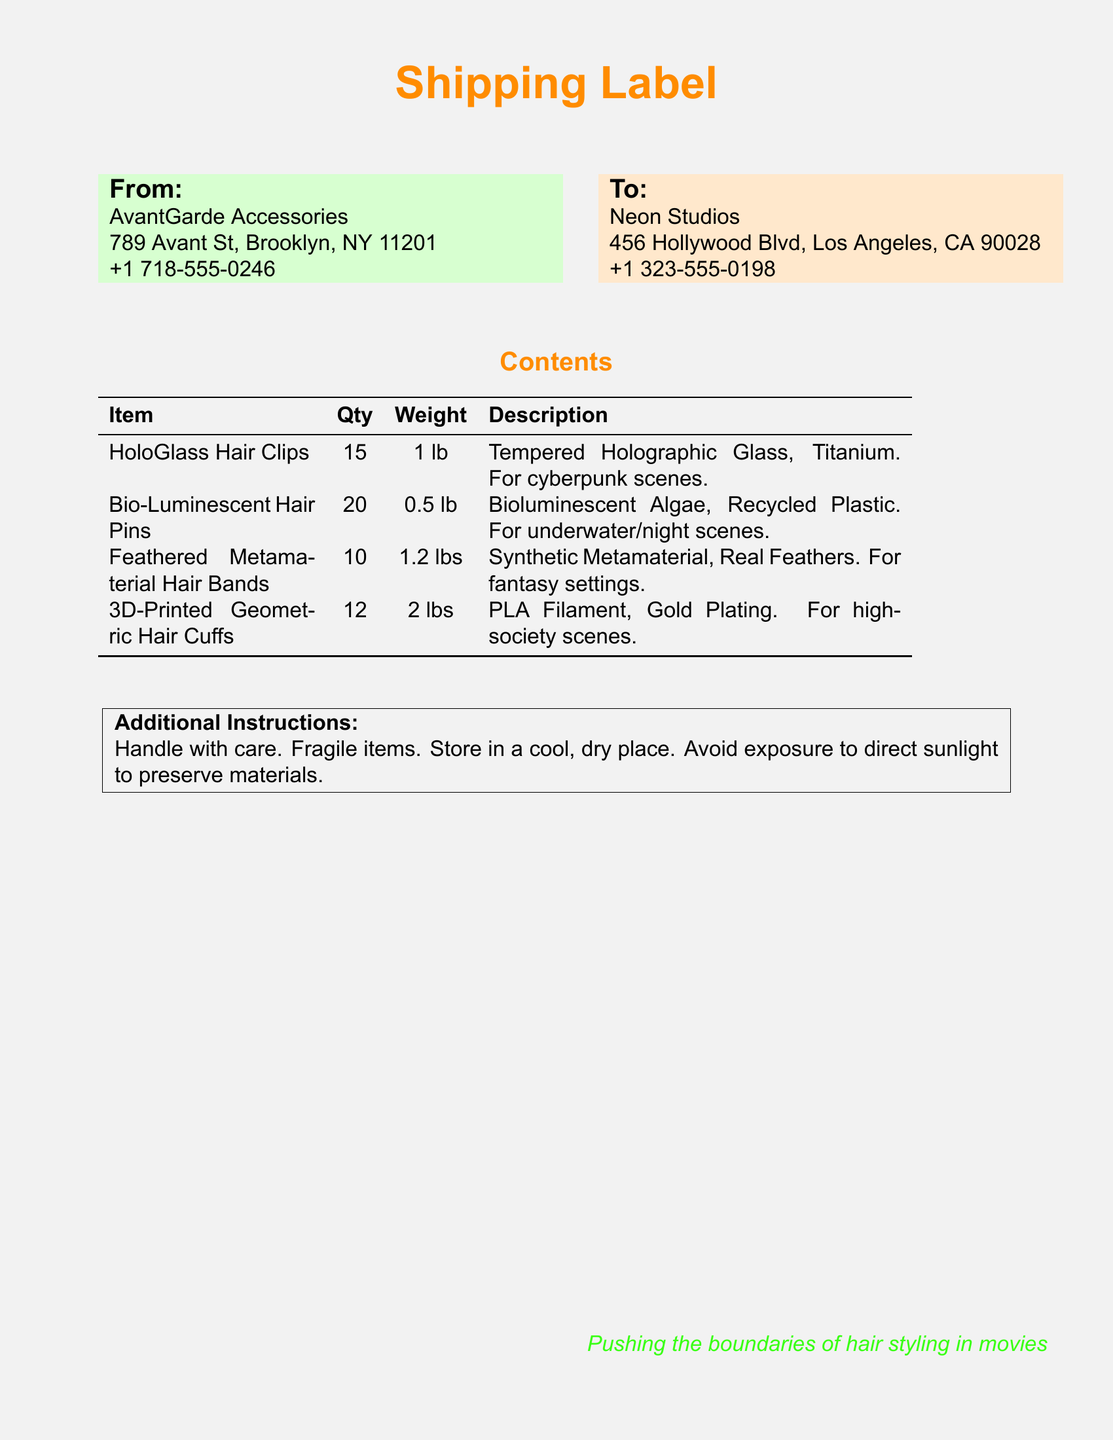what is the weight of the Bio-Luminescent Hair Pins? The document states that the weight of the Bio-Luminescent Hair Pins is 0.5 lb.
Answer: 0.5 lb how many HoloGlass Hair Clips are included? The document indicates that there are 15 HoloGlass Hair Clips included in the shipment.
Answer: 15 what materials are the Feathered Metamaterial Hair Bands made of? The document mentions that the Feathered Metamaterial Hair Bands are made of Synthetic Metamaterial and Real Feathers.
Answer: Synthetic Metamaterial, Real Feathers who is the sender of the shipment? The document lists AvantGarde Accessories as the sender of the shipment.
Answer: AvantGarde Accessories what precautions are mentioned for handling the contents? The document provides instructions to handle the items with care and notes that they are fragile.
Answer: Handle with care, fragile items what is the address of the recipient? The document provides the recipient's address as 456 Hollywood Blvd, Los Angeles, CA 90028.
Answer: 456 Hollywood Blvd, Los Angeles, CA 90028 how many items are shipped in total? The document lists a total of 15 + 20 + 10 + 12 items, giving a total of 57 items in the shipment.
Answer: 57 which hair accessory is designed for underwater/night scenes? The document states that the Bio-Luminescent Hair Pins are designed for underwater/night scenes.
Answer: Bio-Luminescent Hair Pins 